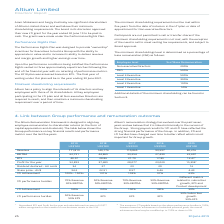From Altium Limited's financial document, What are the LTI performance hurdles in 2019? The document shows two values: 50% Revenue and 50% EPS. From the document: "50% EPS EPS EPS EPS 50% Revenue 50% EBITDA..." Also, What is the share price  in 2019? According to the financial document, $34.2. The relevant text states: "Share price - AU$ price - AU$ 34.2 22.51 8.57 6.46 4.43..." Also, What are the STI performance hurdles in 2019? The document shows two values: 70% Revenue and 30% EBITDA. From the document: "STI performance hurdles 70% Revenue 30% EBITDA STI performance hurdles 70% Revenue 30% EBITDA..." Also, can you calculate: What is the percentage change in the revenue from 2018 to 2019? To answer this question, I need to perform calculations using the financial data. The calculation is: (171,819-140,176)/140,176, which equals 22.57 (percentage). This is based on the information: "Revenue 171,819 140,176 110,865 93,597 80,216 Revenue 171,819 140,176 110,865 93,597 80,216..." The key data points involved are: 140,176, 171,819. Also, can you calculate: What is the percentage change in profits from 2018 to 2019? To answer this question, I need to perform calculations using the financial data. The calculation is: (52,893-37,489)/37,489, which equals 41.09 (percentage). This is based on the information: "Profit for the year 52,893 37,489 28,077 23,020 15,398 1 Profit for the year 52,893 37,489 28,077 23,020 15,398 1..." The key data points involved are: 37,489, 52,893. Also, can you calculate: What is the percentage change in EBITDA from 2017 to 2018? To answer this question, I need to perform calculations using the financial data. The calculation is: (44,869-33,254)/33,254, which equals 34.93 (percentage). This is based on the information: "EBITDA 62,721 44,869 33,254 27,430 22,697 EBITDA 62,721 44,869 33,254 27,430 22,697..." The key data points involved are: 33,254, 44,869. 